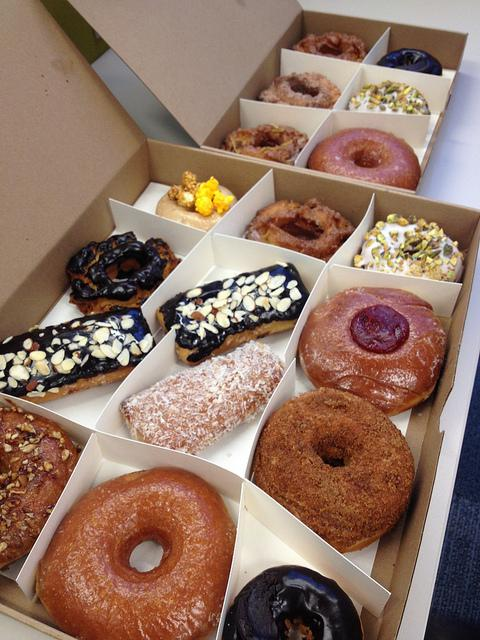What is the most common topping on the frosting? Please explain your reasoning. nuts. At least five of the donuts visible in this image have chopped pieces of nuts on them making them the most common frosting topping. 